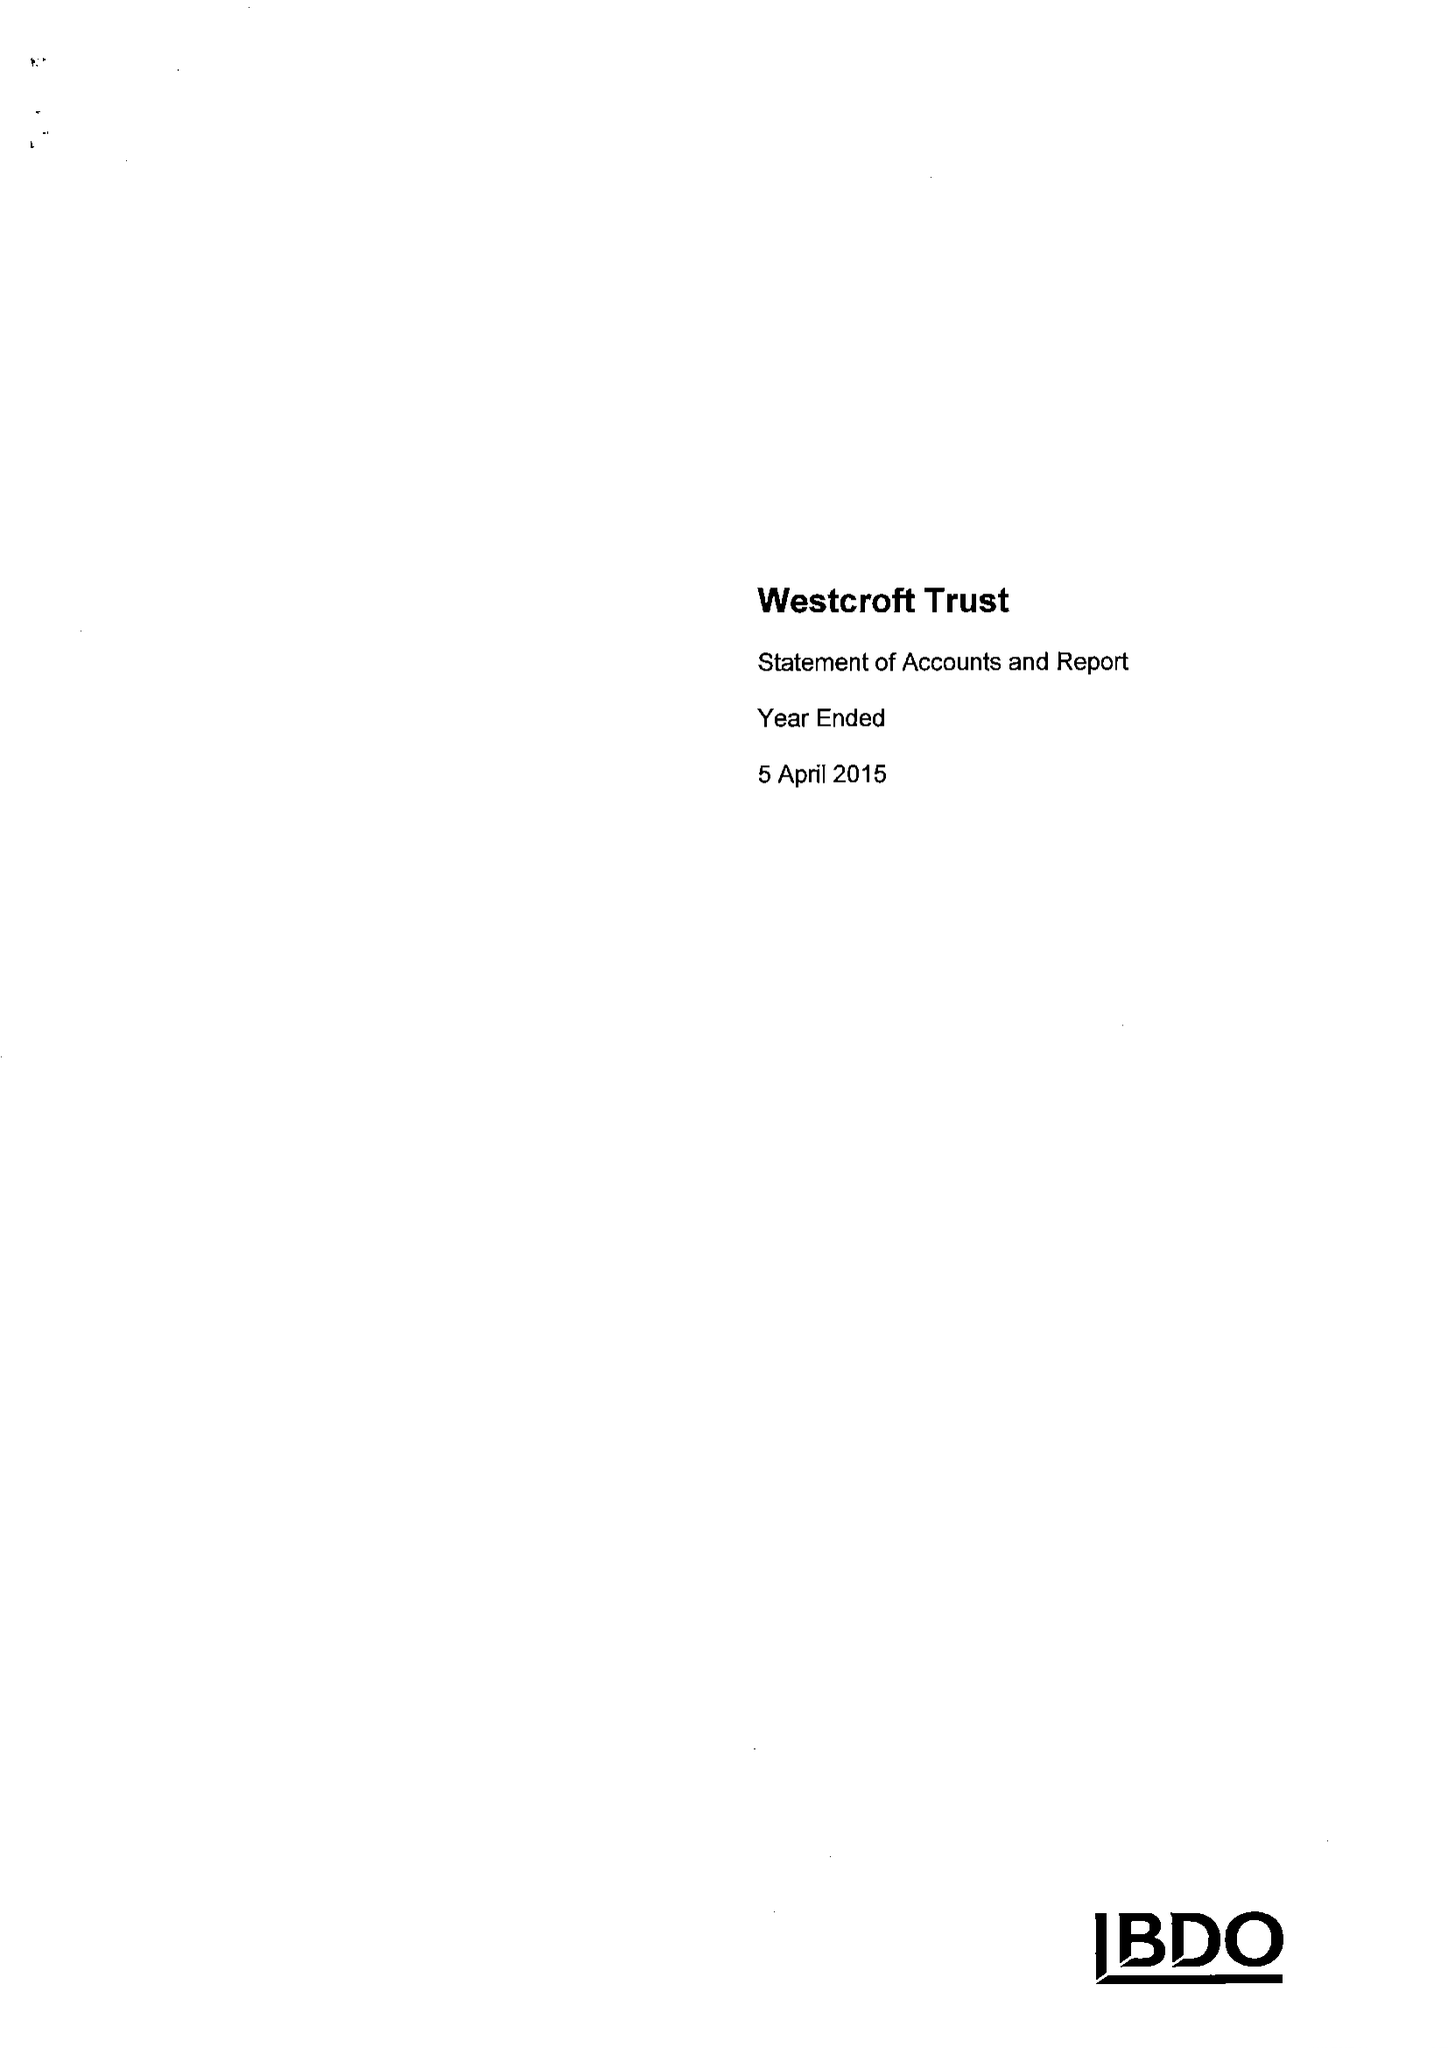What is the value for the charity_number?
Answer the question using a single word or phrase. 212931 